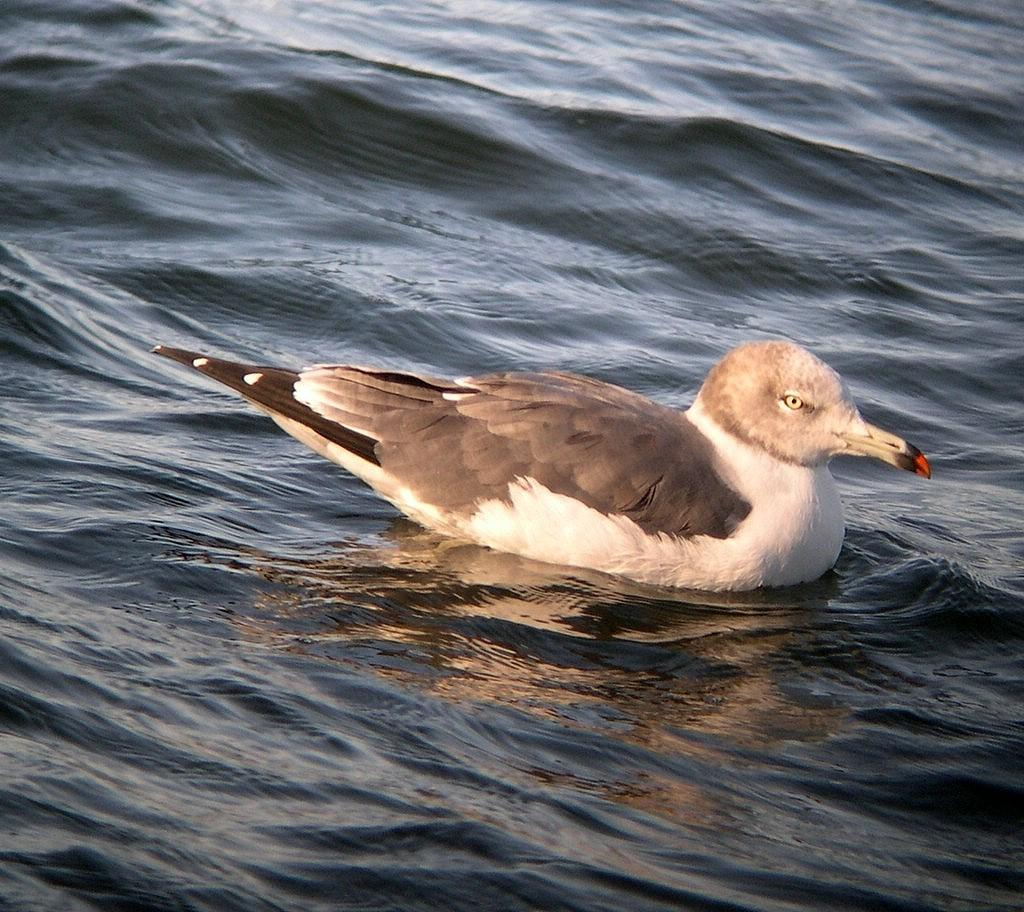What animal is present in the picture? There is a duck in the picture. What is the duck doing in the picture? The duck is swimming on the water surface. Where is the flame located in the picture? There is no flame present in the picture; it features a duck swimming on the water surface. What type of car can be seen driving through the water in the picture? There is no car present in the picture; it features a duck swimming on the water surface. 